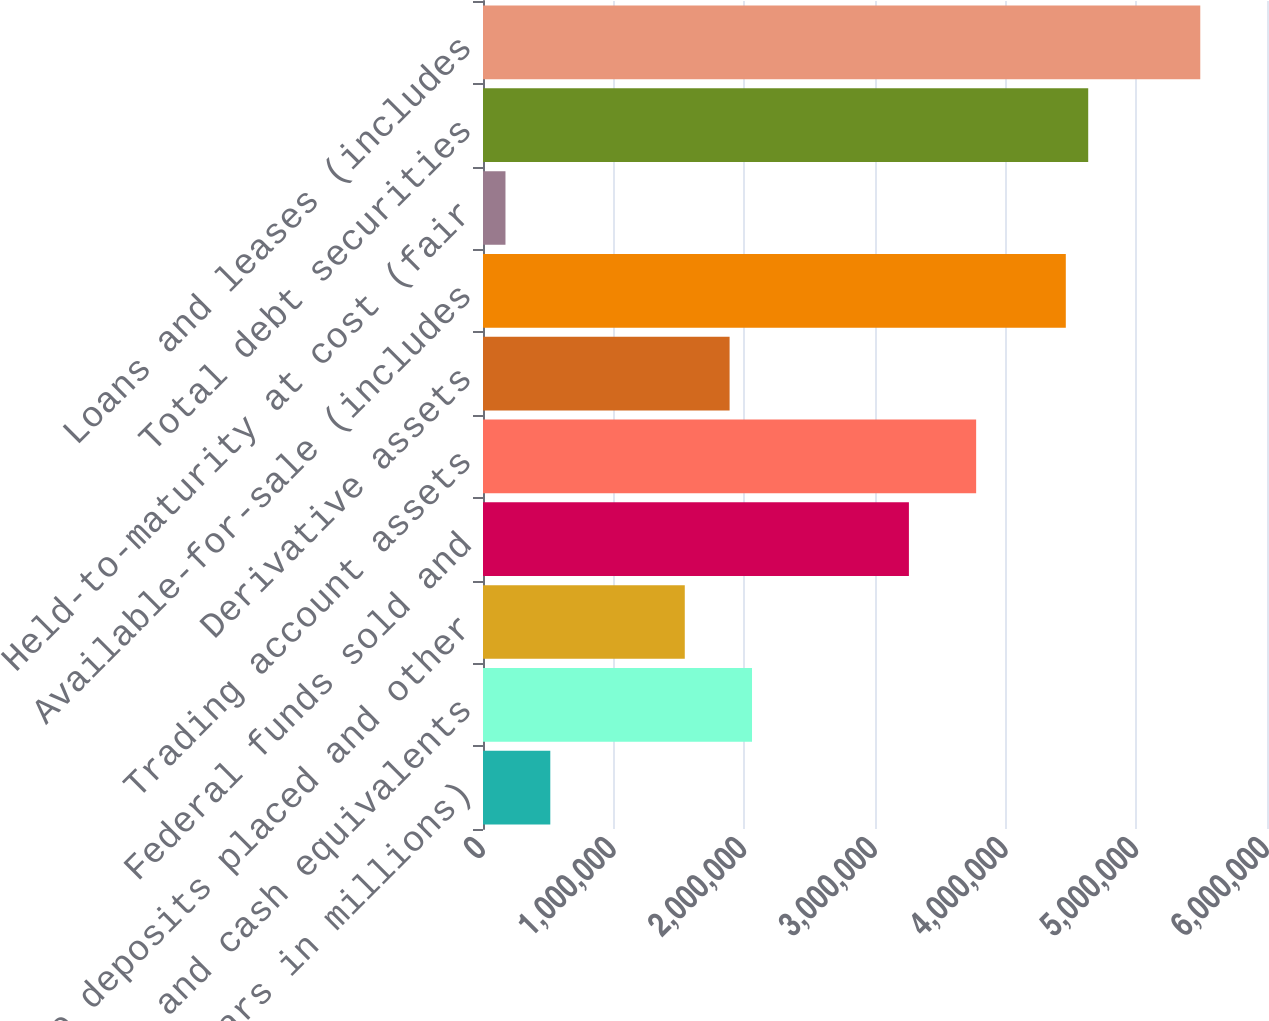<chart> <loc_0><loc_0><loc_500><loc_500><bar_chart><fcel>(Dollars in millions)<fcel>Cash and cash equivalents<fcel>Time deposits placed and other<fcel>Federal funds sold and<fcel>Trading account assets<fcel>Derivative assets<fcel>Available-for-sale (includes<fcel>Held-to-maturity at cost (fair<fcel>Total debt securities<fcel>Loans and leases (includes<nl><fcel>515043<fcel>2.0588e+06<fcel>1.54422e+06<fcel>3.25951e+06<fcel>3.77409e+06<fcel>1.88728e+06<fcel>4.46021e+06<fcel>171985<fcel>4.63174e+06<fcel>5.48938e+06<nl></chart> 